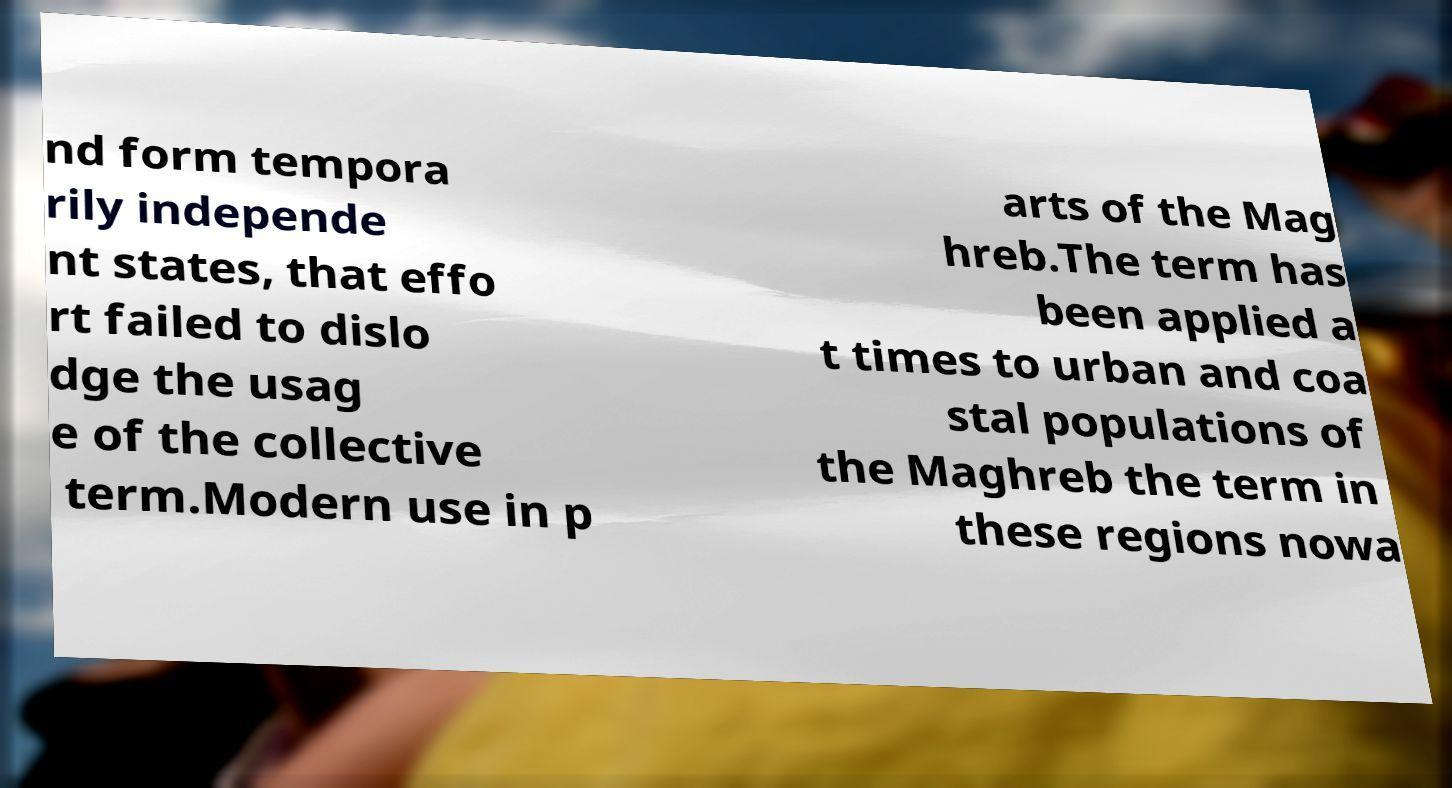For documentation purposes, I need the text within this image transcribed. Could you provide that? nd form tempora rily independe nt states, that effo rt failed to dislo dge the usag e of the collective term.Modern use in p arts of the Mag hreb.The term has been applied a t times to urban and coa stal populations of the Maghreb the term in these regions nowa 